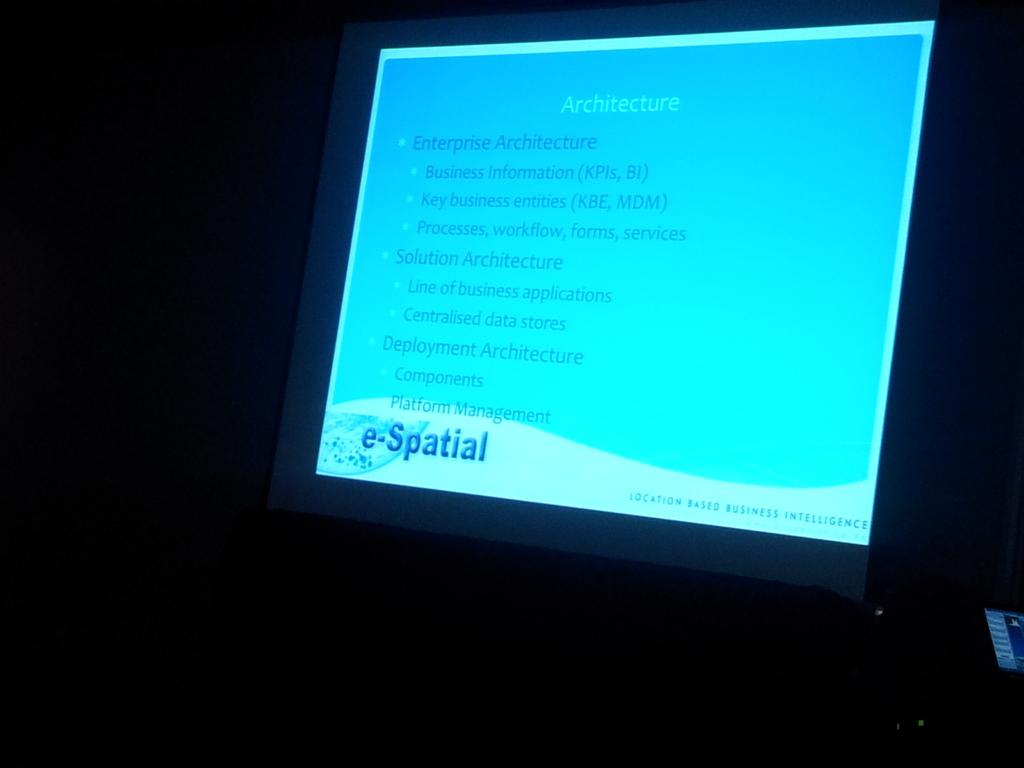<image>
Provide a brief description of the given image. Computer screen about Architecture and the word "e-Spartial" on the bottom. 